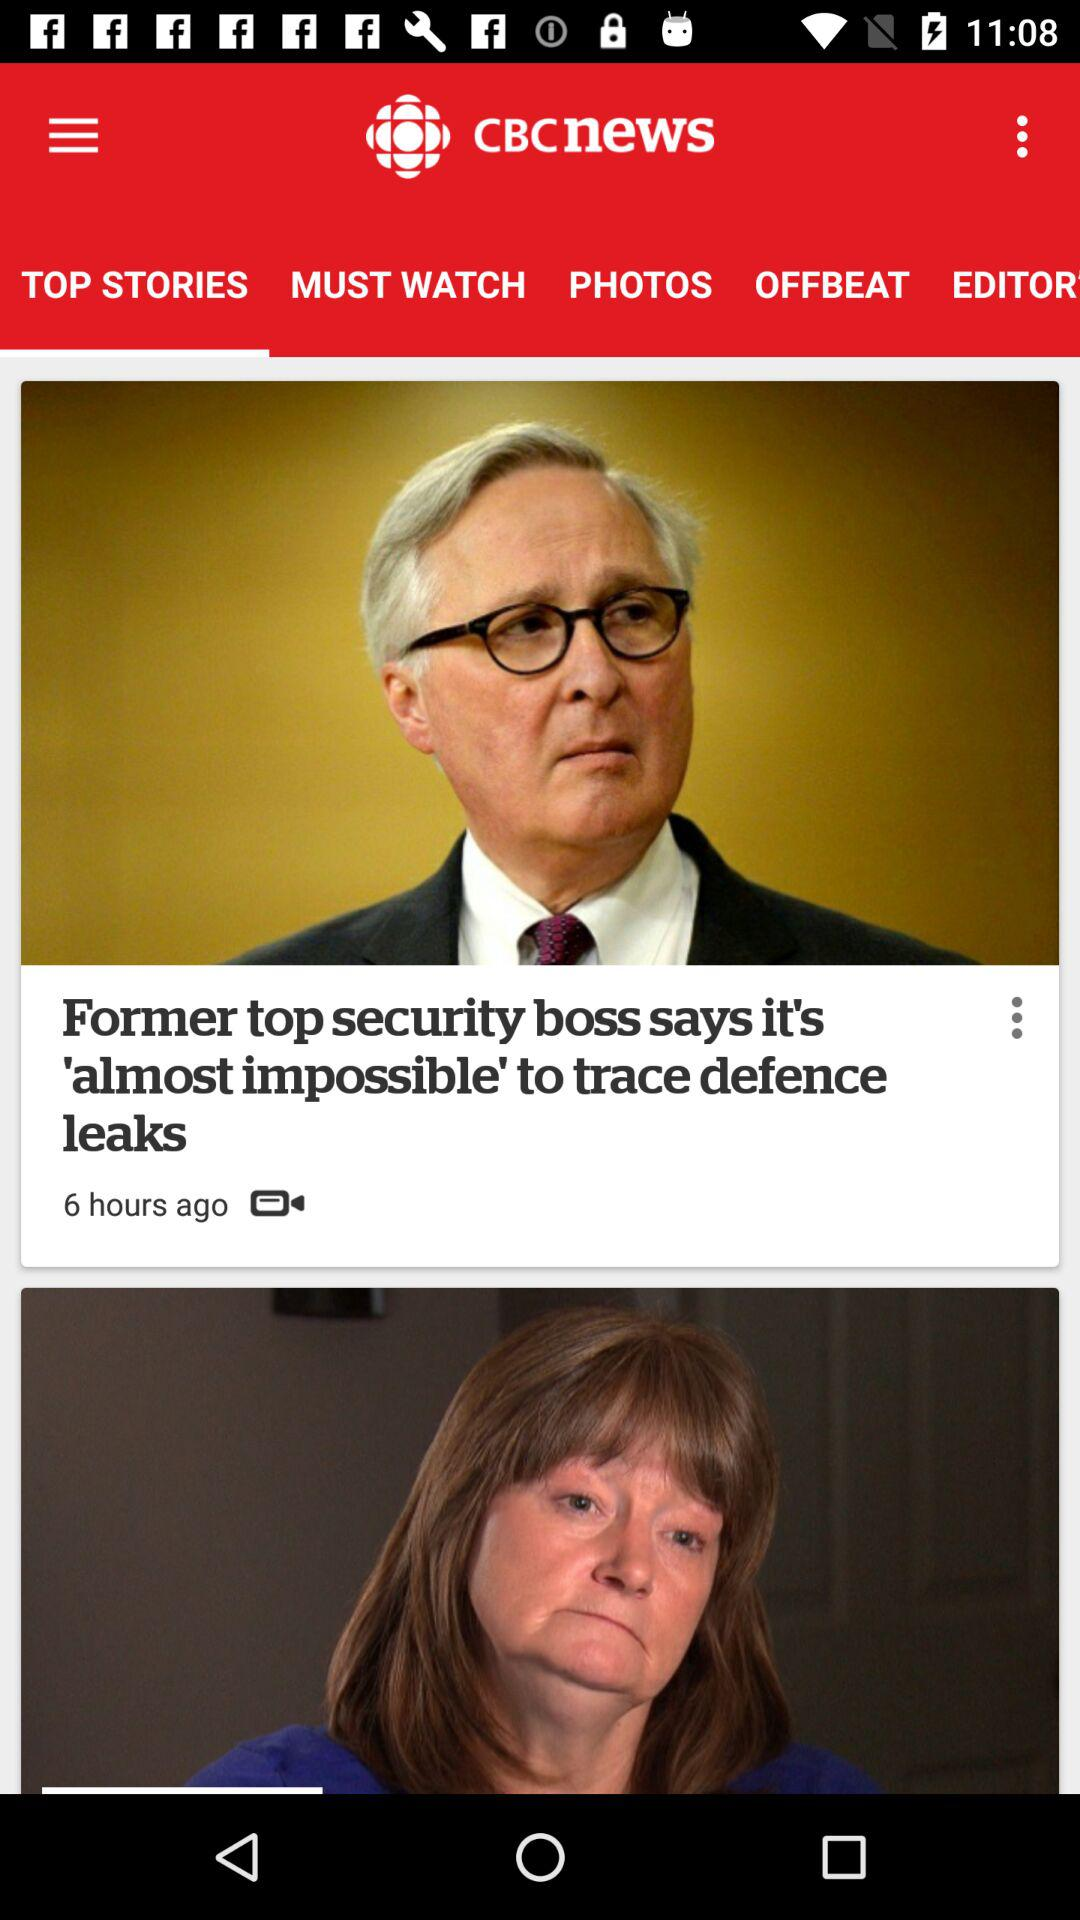What is the app name? The app name is "CBCnews". 